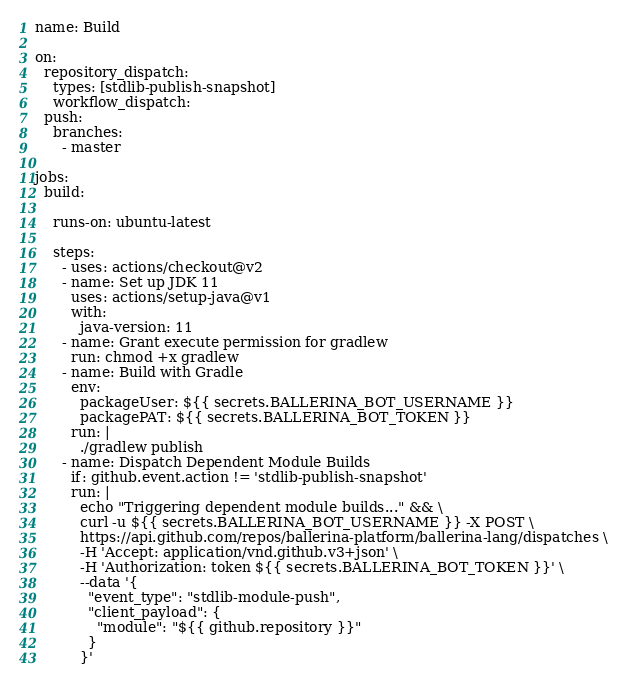<code> <loc_0><loc_0><loc_500><loc_500><_YAML_>name: Build

on:
  repository_dispatch:
    types: [stdlib-publish-snapshot]
    workflow_dispatch:
  push:
    branches:
      - master

jobs:
  build:

    runs-on: ubuntu-latest

    steps:
      - uses: actions/checkout@v2
      - name: Set up JDK 11
        uses: actions/setup-java@v1
        with:
          java-version: 11
      - name: Grant execute permission for gradlew
        run: chmod +x gradlew
      - name: Build with Gradle
        env:
          packageUser: ${{ secrets.BALLERINA_BOT_USERNAME }}
          packagePAT: ${{ secrets.BALLERINA_BOT_TOKEN }}
        run: |
          ./gradlew publish
      - name: Dispatch Dependent Module Builds
        if: github.event.action != 'stdlib-publish-snapshot'
        run: |
          echo "Triggering dependent module builds..." && \
          curl -u ${{ secrets.BALLERINA_BOT_USERNAME }} -X POST \
          https://api.github.com/repos/ballerina-platform/ballerina-lang/dispatches \
          -H 'Accept: application/vnd.github.v3+json' \
          -H 'Authorization: token ${{ secrets.BALLERINA_BOT_TOKEN }}' \
          --data '{
            "event_type": "stdlib-module-push",
            "client_payload": {
              "module": "${{ github.repository }}"
            }
          }'
</code> 